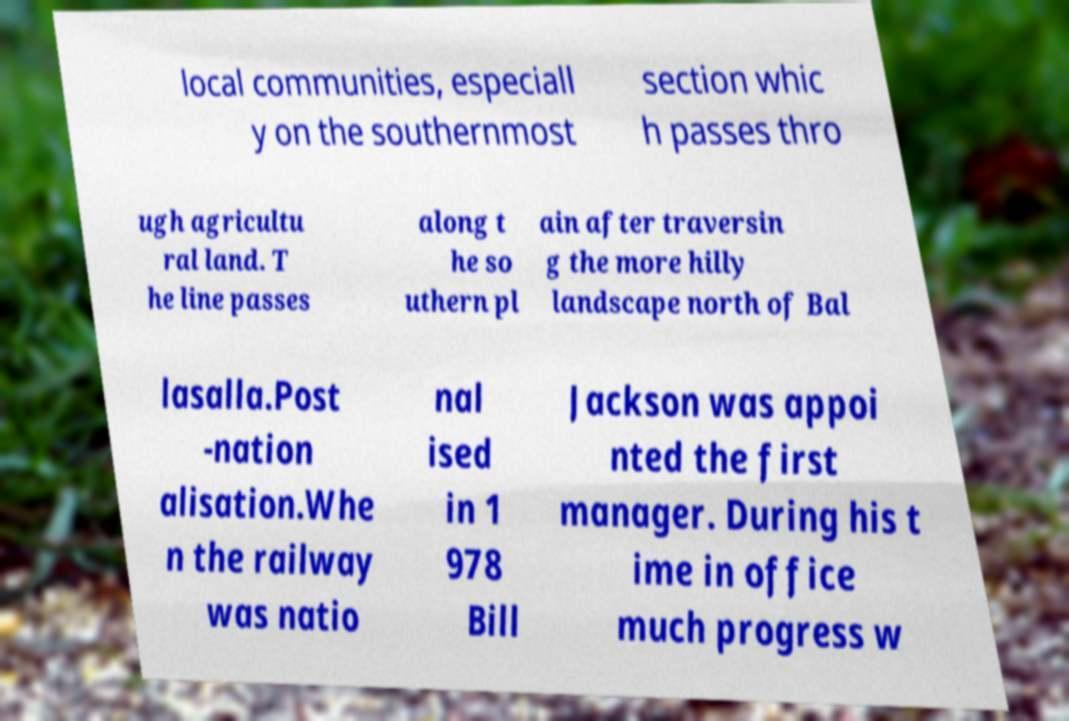Please identify and transcribe the text found in this image. local communities, especiall y on the southernmost section whic h passes thro ugh agricultu ral land. T he line passes along t he so uthern pl ain after traversin g the more hilly landscape north of Bal lasalla.Post -nation alisation.Whe n the railway was natio nal ised in 1 978 Bill Jackson was appoi nted the first manager. During his t ime in office much progress w 